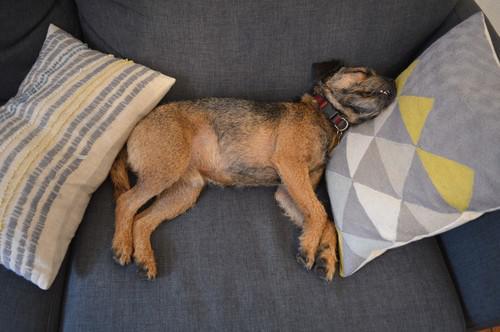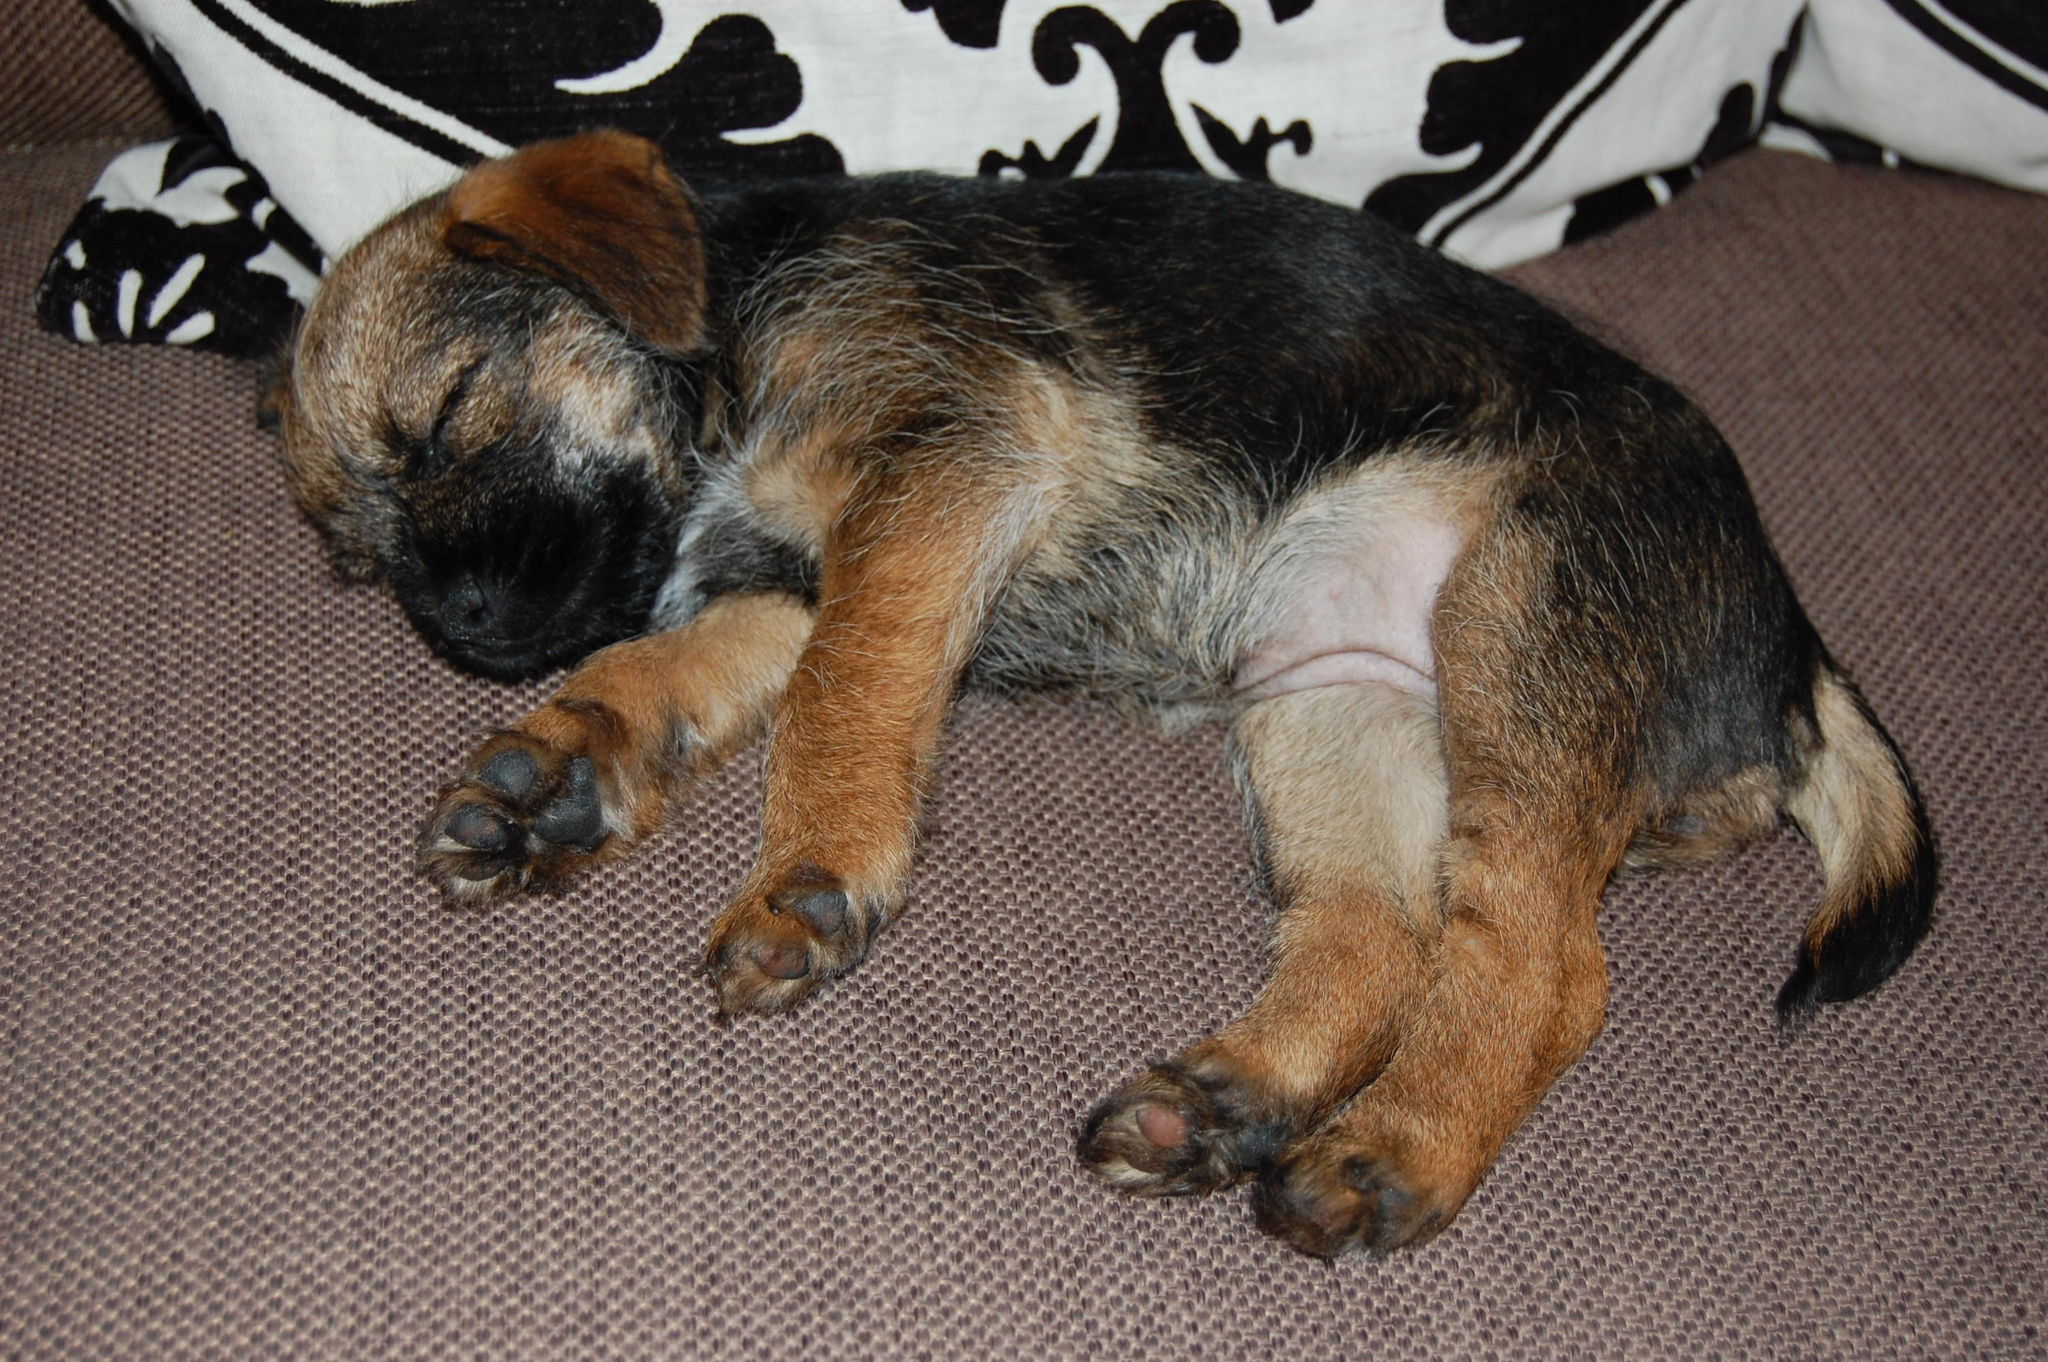The first image is the image on the left, the second image is the image on the right. Considering the images on both sides, is "At least one dog is sleeping on a throw pillow." valid? Answer yes or no. Yes. The first image is the image on the left, the second image is the image on the right. Considering the images on both sides, is "One dog is sleeping on a piece of furniture with its head resting against a squarish patterned pillow." valid? Answer yes or no. Yes. 